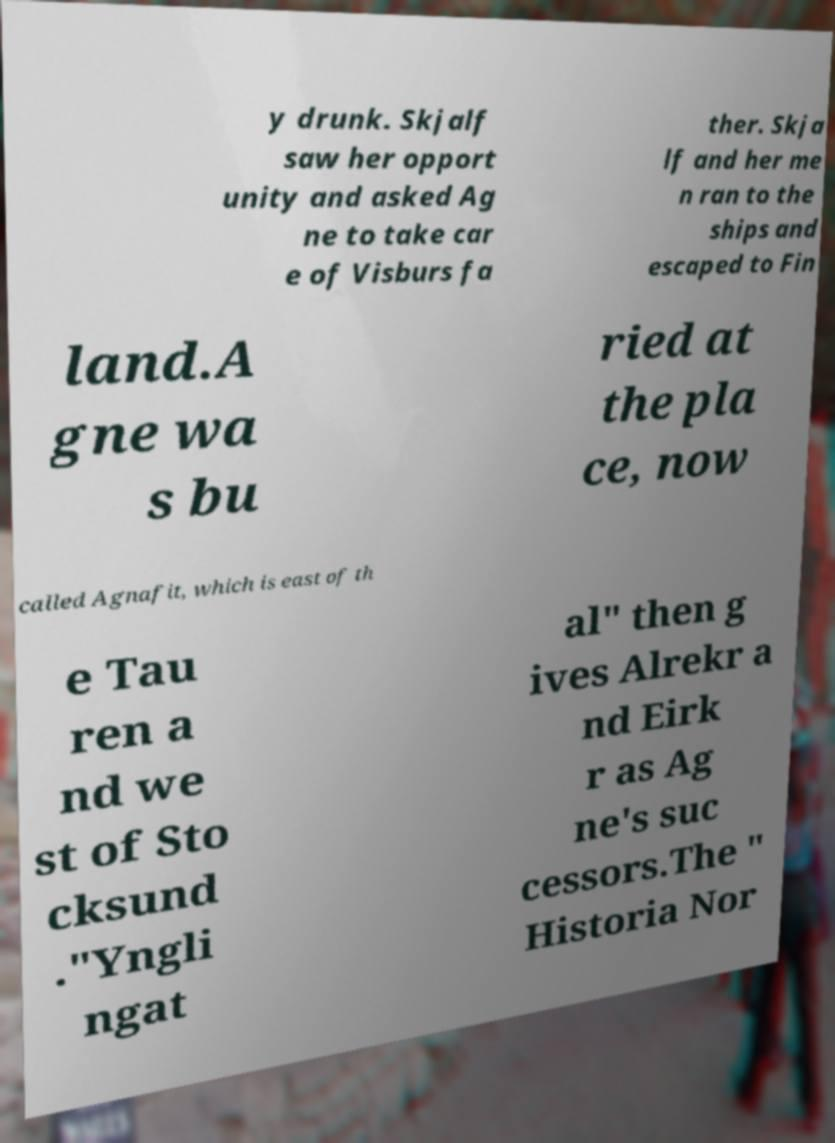Can you read and provide the text displayed in the image?This photo seems to have some interesting text. Can you extract and type it out for me? y drunk. Skjalf saw her opport unity and asked Ag ne to take car e of Visburs fa ther. Skja lf and her me n ran to the ships and escaped to Fin land.A gne wa s bu ried at the pla ce, now called Agnafit, which is east of th e Tau ren a nd we st of Sto cksund ."Yngli ngat al" then g ives Alrekr a nd Eirk r as Ag ne's suc cessors.The " Historia Nor 